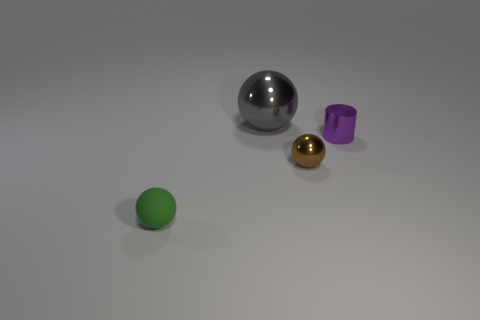Subtract all small spheres. How many spheres are left? 1 Add 2 tiny brown spheres. How many objects exist? 6 Subtract all cylinders. How many objects are left? 3 Subtract 1 spheres. How many spheres are left? 2 Add 4 gray balls. How many gray balls exist? 5 Subtract 0 blue balls. How many objects are left? 4 Subtract all red cylinders. Subtract all green spheres. How many cylinders are left? 1 Subtract all big yellow rubber objects. Subtract all tiny green objects. How many objects are left? 3 Add 3 gray shiny spheres. How many gray shiny spheres are left? 4 